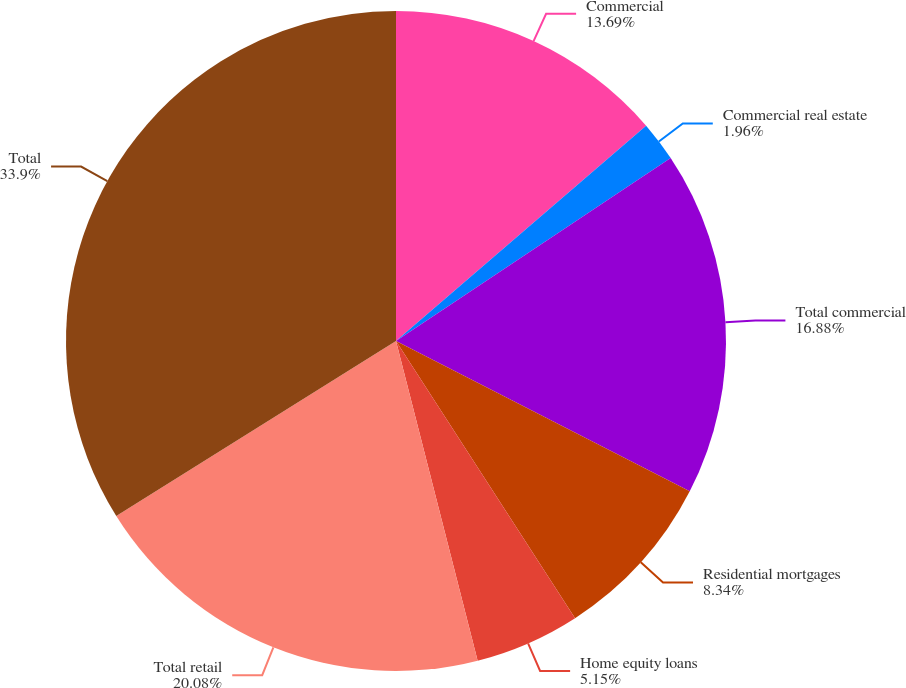Convert chart to OTSL. <chart><loc_0><loc_0><loc_500><loc_500><pie_chart><fcel>Commercial<fcel>Commercial real estate<fcel>Total commercial<fcel>Residential mortgages<fcel>Home equity loans<fcel>Total retail<fcel>Total<nl><fcel>13.69%<fcel>1.96%<fcel>16.88%<fcel>8.34%<fcel>5.15%<fcel>20.08%<fcel>33.9%<nl></chart> 